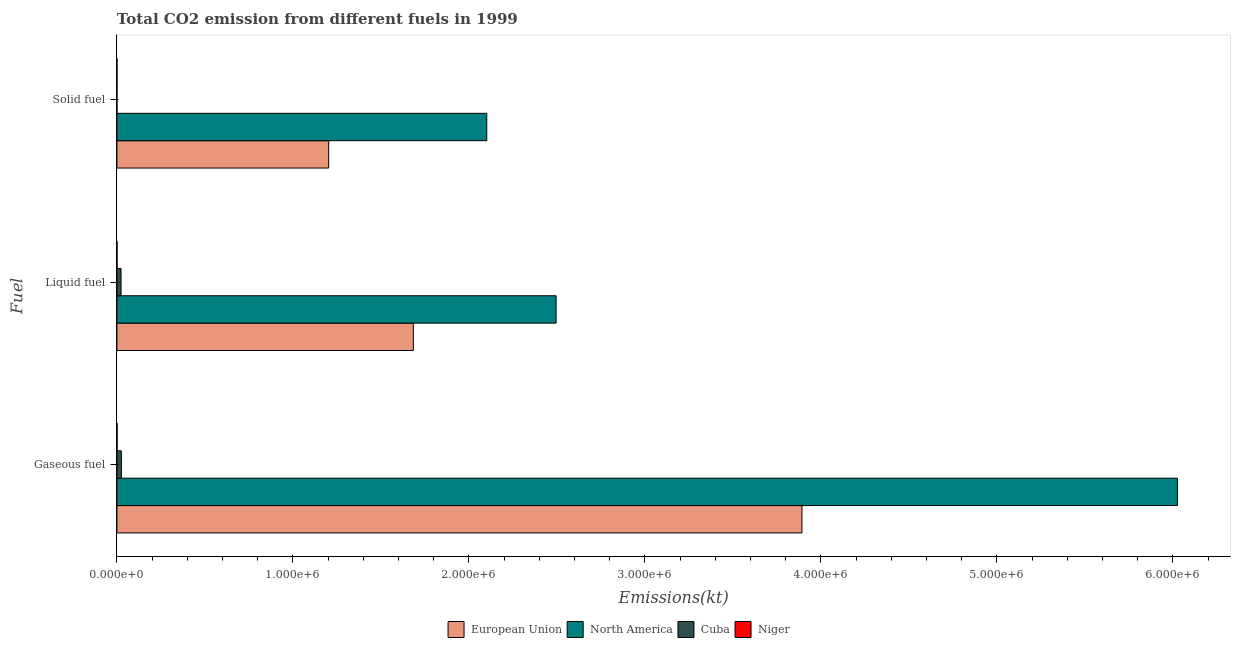How many groups of bars are there?
Give a very brief answer. 3. Are the number of bars per tick equal to the number of legend labels?
Make the answer very short. Yes. Are the number of bars on each tick of the Y-axis equal?
Your response must be concise. Yes. How many bars are there on the 2nd tick from the top?
Provide a succinct answer. 4. How many bars are there on the 3rd tick from the bottom?
Provide a succinct answer. 4. What is the label of the 2nd group of bars from the top?
Offer a terse response. Liquid fuel. What is the amount of co2 emissions from solid fuel in Niger?
Your answer should be very brief. 348.37. Across all countries, what is the maximum amount of co2 emissions from gaseous fuel?
Your answer should be very brief. 6.03e+06. Across all countries, what is the minimum amount of co2 emissions from gaseous fuel?
Give a very brief answer. 1059.76. In which country was the amount of co2 emissions from gaseous fuel minimum?
Provide a short and direct response. Niger. What is the total amount of co2 emissions from liquid fuel in the graph?
Provide a short and direct response. 4.20e+06. What is the difference between the amount of co2 emissions from solid fuel in Niger and that in European Union?
Offer a very short reply. -1.20e+06. What is the difference between the amount of co2 emissions from gaseous fuel in North America and the amount of co2 emissions from solid fuel in Cuba?
Your response must be concise. 6.03e+06. What is the average amount of co2 emissions from liquid fuel per country?
Offer a very short reply. 1.05e+06. What is the difference between the amount of co2 emissions from solid fuel and amount of co2 emissions from gaseous fuel in Niger?
Ensure brevity in your answer.  -711.4. What is the ratio of the amount of co2 emissions from solid fuel in Cuba to that in Niger?
Offer a terse response. 0.26. Is the amount of co2 emissions from solid fuel in North America less than that in European Union?
Give a very brief answer. No. What is the difference between the highest and the second highest amount of co2 emissions from liquid fuel?
Provide a succinct answer. 8.11e+05. What is the difference between the highest and the lowest amount of co2 emissions from liquid fuel?
Give a very brief answer. 2.49e+06. What does the 3rd bar from the bottom in Solid fuel represents?
Ensure brevity in your answer.  Cuba. How many countries are there in the graph?
Your response must be concise. 4. What is the difference between two consecutive major ticks on the X-axis?
Provide a short and direct response. 1.00e+06. Are the values on the major ticks of X-axis written in scientific E-notation?
Keep it short and to the point. Yes. Does the graph contain any zero values?
Offer a terse response. No. Where does the legend appear in the graph?
Provide a short and direct response. Bottom center. How many legend labels are there?
Your response must be concise. 4. What is the title of the graph?
Your answer should be compact. Total CO2 emission from different fuels in 1999. Does "Uruguay" appear as one of the legend labels in the graph?
Offer a terse response. No. What is the label or title of the X-axis?
Offer a terse response. Emissions(kt). What is the label or title of the Y-axis?
Give a very brief answer. Fuel. What is the Emissions(kt) in European Union in Gaseous fuel?
Your answer should be very brief. 3.89e+06. What is the Emissions(kt) in North America in Gaseous fuel?
Ensure brevity in your answer.  6.03e+06. What is the Emissions(kt) of Cuba in Gaseous fuel?
Your response must be concise. 2.53e+04. What is the Emissions(kt) in Niger in Gaseous fuel?
Ensure brevity in your answer.  1059.76. What is the Emissions(kt) in European Union in Liquid fuel?
Provide a short and direct response. 1.68e+06. What is the Emissions(kt) of North America in Liquid fuel?
Your answer should be very brief. 2.50e+06. What is the Emissions(kt) in Cuba in Liquid fuel?
Offer a terse response. 2.35e+04. What is the Emissions(kt) of Niger in Liquid fuel?
Your answer should be very brief. 693.06. What is the Emissions(kt) in European Union in Solid fuel?
Your answer should be compact. 1.20e+06. What is the Emissions(kt) of North America in Solid fuel?
Provide a short and direct response. 2.10e+06. What is the Emissions(kt) of Cuba in Solid fuel?
Your answer should be very brief. 91.67. What is the Emissions(kt) in Niger in Solid fuel?
Provide a succinct answer. 348.37. Across all Fuel, what is the maximum Emissions(kt) in European Union?
Offer a terse response. 3.89e+06. Across all Fuel, what is the maximum Emissions(kt) of North America?
Provide a short and direct response. 6.03e+06. Across all Fuel, what is the maximum Emissions(kt) in Cuba?
Keep it short and to the point. 2.53e+04. Across all Fuel, what is the maximum Emissions(kt) of Niger?
Offer a very short reply. 1059.76. Across all Fuel, what is the minimum Emissions(kt) in European Union?
Offer a terse response. 1.20e+06. Across all Fuel, what is the minimum Emissions(kt) in North America?
Your response must be concise. 2.10e+06. Across all Fuel, what is the minimum Emissions(kt) in Cuba?
Ensure brevity in your answer.  91.67. Across all Fuel, what is the minimum Emissions(kt) of Niger?
Give a very brief answer. 348.37. What is the total Emissions(kt) of European Union in the graph?
Keep it short and to the point. 6.78e+06. What is the total Emissions(kt) in North America in the graph?
Keep it short and to the point. 1.06e+07. What is the total Emissions(kt) of Cuba in the graph?
Provide a succinct answer. 4.89e+04. What is the total Emissions(kt) in Niger in the graph?
Ensure brevity in your answer.  2101.19. What is the difference between the Emissions(kt) in European Union in Gaseous fuel and that in Liquid fuel?
Your answer should be very brief. 2.21e+06. What is the difference between the Emissions(kt) in North America in Gaseous fuel and that in Liquid fuel?
Your answer should be very brief. 3.53e+06. What is the difference between the Emissions(kt) of Cuba in Gaseous fuel and that in Liquid fuel?
Give a very brief answer. 1866.5. What is the difference between the Emissions(kt) of Niger in Gaseous fuel and that in Liquid fuel?
Give a very brief answer. 366.7. What is the difference between the Emissions(kt) in European Union in Gaseous fuel and that in Solid fuel?
Give a very brief answer. 2.69e+06. What is the difference between the Emissions(kt) of North America in Gaseous fuel and that in Solid fuel?
Ensure brevity in your answer.  3.92e+06. What is the difference between the Emissions(kt) of Cuba in Gaseous fuel and that in Solid fuel?
Offer a terse response. 2.52e+04. What is the difference between the Emissions(kt) of Niger in Gaseous fuel and that in Solid fuel?
Offer a terse response. 711.4. What is the difference between the Emissions(kt) of European Union in Liquid fuel and that in Solid fuel?
Provide a short and direct response. 4.81e+05. What is the difference between the Emissions(kt) of North America in Liquid fuel and that in Solid fuel?
Keep it short and to the point. 3.94e+05. What is the difference between the Emissions(kt) of Cuba in Liquid fuel and that in Solid fuel?
Keep it short and to the point. 2.34e+04. What is the difference between the Emissions(kt) of Niger in Liquid fuel and that in Solid fuel?
Your answer should be compact. 344.7. What is the difference between the Emissions(kt) of European Union in Gaseous fuel and the Emissions(kt) of North America in Liquid fuel?
Ensure brevity in your answer.  1.40e+06. What is the difference between the Emissions(kt) in European Union in Gaseous fuel and the Emissions(kt) in Cuba in Liquid fuel?
Make the answer very short. 3.87e+06. What is the difference between the Emissions(kt) in European Union in Gaseous fuel and the Emissions(kt) in Niger in Liquid fuel?
Make the answer very short. 3.89e+06. What is the difference between the Emissions(kt) in North America in Gaseous fuel and the Emissions(kt) in Cuba in Liquid fuel?
Give a very brief answer. 6.00e+06. What is the difference between the Emissions(kt) of North America in Gaseous fuel and the Emissions(kt) of Niger in Liquid fuel?
Provide a short and direct response. 6.03e+06. What is the difference between the Emissions(kt) of Cuba in Gaseous fuel and the Emissions(kt) of Niger in Liquid fuel?
Provide a succinct answer. 2.46e+04. What is the difference between the Emissions(kt) of European Union in Gaseous fuel and the Emissions(kt) of North America in Solid fuel?
Provide a succinct answer. 1.79e+06. What is the difference between the Emissions(kt) of European Union in Gaseous fuel and the Emissions(kt) of Cuba in Solid fuel?
Ensure brevity in your answer.  3.89e+06. What is the difference between the Emissions(kt) in European Union in Gaseous fuel and the Emissions(kt) in Niger in Solid fuel?
Offer a terse response. 3.89e+06. What is the difference between the Emissions(kt) of North America in Gaseous fuel and the Emissions(kt) of Cuba in Solid fuel?
Ensure brevity in your answer.  6.03e+06. What is the difference between the Emissions(kt) of North America in Gaseous fuel and the Emissions(kt) of Niger in Solid fuel?
Provide a succinct answer. 6.03e+06. What is the difference between the Emissions(kt) in Cuba in Gaseous fuel and the Emissions(kt) in Niger in Solid fuel?
Your answer should be very brief. 2.50e+04. What is the difference between the Emissions(kt) of European Union in Liquid fuel and the Emissions(kt) of North America in Solid fuel?
Offer a very short reply. -4.17e+05. What is the difference between the Emissions(kt) in European Union in Liquid fuel and the Emissions(kt) in Cuba in Solid fuel?
Offer a very short reply. 1.68e+06. What is the difference between the Emissions(kt) of European Union in Liquid fuel and the Emissions(kt) of Niger in Solid fuel?
Keep it short and to the point. 1.68e+06. What is the difference between the Emissions(kt) in North America in Liquid fuel and the Emissions(kt) in Cuba in Solid fuel?
Give a very brief answer. 2.50e+06. What is the difference between the Emissions(kt) in North America in Liquid fuel and the Emissions(kt) in Niger in Solid fuel?
Provide a short and direct response. 2.50e+06. What is the difference between the Emissions(kt) of Cuba in Liquid fuel and the Emissions(kt) of Niger in Solid fuel?
Provide a succinct answer. 2.31e+04. What is the average Emissions(kt) in European Union per Fuel?
Offer a very short reply. 2.26e+06. What is the average Emissions(kt) of North America per Fuel?
Ensure brevity in your answer.  3.54e+06. What is the average Emissions(kt) of Cuba per Fuel?
Offer a terse response. 1.63e+04. What is the average Emissions(kt) of Niger per Fuel?
Provide a short and direct response. 700.4. What is the difference between the Emissions(kt) in European Union and Emissions(kt) in North America in Gaseous fuel?
Your answer should be compact. -2.13e+06. What is the difference between the Emissions(kt) of European Union and Emissions(kt) of Cuba in Gaseous fuel?
Make the answer very short. 3.87e+06. What is the difference between the Emissions(kt) in European Union and Emissions(kt) in Niger in Gaseous fuel?
Ensure brevity in your answer.  3.89e+06. What is the difference between the Emissions(kt) in North America and Emissions(kt) in Cuba in Gaseous fuel?
Offer a very short reply. 6.00e+06. What is the difference between the Emissions(kt) of North America and Emissions(kt) of Niger in Gaseous fuel?
Your response must be concise. 6.03e+06. What is the difference between the Emissions(kt) of Cuba and Emissions(kt) of Niger in Gaseous fuel?
Keep it short and to the point. 2.43e+04. What is the difference between the Emissions(kt) in European Union and Emissions(kt) in North America in Liquid fuel?
Offer a terse response. -8.11e+05. What is the difference between the Emissions(kt) of European Union and Emissions(kt) of Cuba in Liquid fuel?
Your answer should be compact. 1.66e+06. What is the difference between the Emissions(kt) in European Union and Emissions(kt) in Niger in Liquid fuel?
Make the answer very short. 1.68e+06. What is the difference between the Emissions(kt) in North America and Emissions(kt) in Cuba in Liquid fuel?
Provide a short and direct response. 2.47e+06. What is the difference between the Emissions(kt) in North America and Emissions(kt) in Niger in Liquid fuel?
Your answer should be compact. 2.49e+06. What is the difference between the Emissions(kt) in Cuba and Emissions(kt) in Niger in Liquid fuel?
Offer a terse response. 2.28e+04. What is the difference between the Emissions(kt) of European Union and Emissions(kt) of North America in Solid fuel?
Give a very brief answer. -8.98e+05. What is the difference between the Emissions(kt) in European Union and Emissions(kt) in Cuba in Solid fuel?
Your answer should be compact. 1.20e+06. What is the difference between the Emissions(kt) of European Union and Emissions(kt) of Niger in Solid fuel?
Offer a terse response. 1.20e+06. What is the difference between the Emissions(kt) in North America and Emissions(kt) in Cuba in Solid fuel?
Make the answer very short. 2.10e+06. What is the difference between the Emissions(kt) in North America and Emissions(kt) in Niger in Solid fuel?
Make the answer very short. 2.10e+06. What is the difference between the Emissions(kt) of Cuba and Emissions(kt) of Niger in Solid fuel?
Give a very brief answer. -256.69. What is the ratio of the Emissions(kt) of European Union in Gaseous fuel to that in Liquid fuel?
Provide a succinct answer. 2.31. What is the ratio of the Emissions(kt) of North America in Gaseous fuel to that in Liquid fuel?
Ensure brevity in your answer.  2.41. What is the ratio of the Emissions(kt) of Cuba in Gaseous fuel to that in Liquid fuel?
Offer a very short reply. 1.08. What is the ratio of the Emissions(kt) in Niger in Gaseous fuel to that in Liquid fuel?
Offer a very short reply. 1.53. What is the ratio of the Emissions(kt) in European Union in Gaseous fuel to that in Solid fuel?
Offer a terse response. 3.24. What is the ratio of the Emissions(kt) of North America in Gaseous fuel to that in Solid fuel?
Your response must be concise. 2.87. What is the ratio of the Emissions(kt) in Cuba in Gaseous fuel to that in Solid fuel?
Offer a terse response. 276.32. What is the ratio of the Emissions(kt) in Niger in Gaseous fuel to that in Solid fuel?
Make the answer very short. 3.04. What is the ratio of the Emissions(kt) in European Union in Liquid fuel to that in Solid fuel?
Make the answer very short. 1.4. What is the ratio of the Emissions(kt) in North America in Liquid fuel to that in Solid fuel?
Your response must be concise. 1.19. What is the ratio of the Emissions(kt) in Cuba in Liquid fuel to that in Solid fuel?
Your response must be concise. 255.96. What is the ratio of the Emissions(kt) in Niger in Liquid fuel to that in Solid fuel?
Give a very brief answer. 1.99. What is the difference between the highest and the second highest Emissions(kt) in European Union?
Offer a terse response. 2.21e+06. What is the difference between the highest and the second highest Emissions(kt) of North America?
Your answer should be very brief. 3.53e+06. What is the difference between the highest and the second highest Emissions(kt) in Cuba?
Make the answer very short. 1866.5. What is the difference between the highest and the second highest Emissions(kt) of Niger?
Ensure brevity in your answer.  366.7. What is the difference between the highest and the lowest Emissions(kt) of European Union?
Your answer should be compact. 2.69e+06. What is the difference between the highest and the lowest Emissions(kt) of North America?
Your answer should be very brief. 3.92e+06. What is the difference between the highest and the lowest Emissions(kt) of Cuba?
Keep it short and to the point. 2.52e+04. What is the difference between the highest and the lowest Emissions(kt) of Niger?
Your answer should be compact. 711.4. 